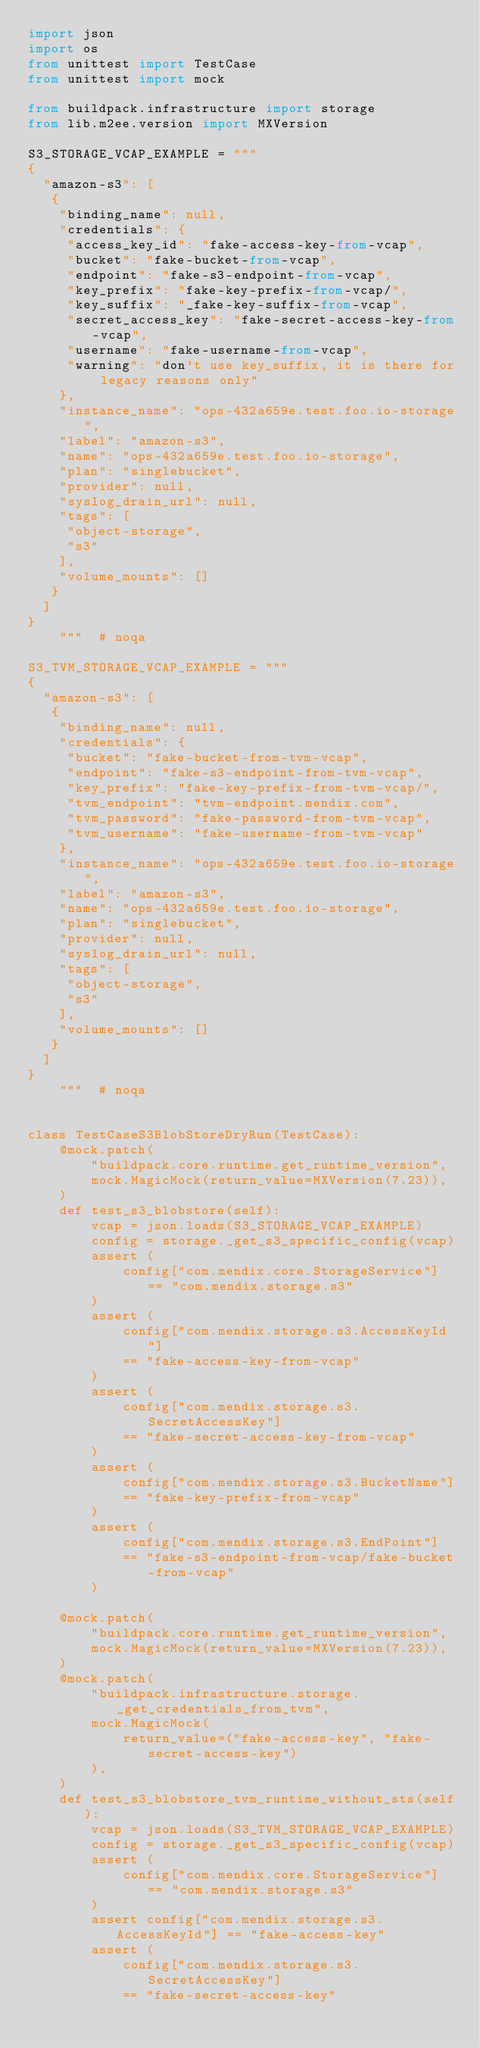<code> <loc_0><loc_0><loc_500><loc_500><_Python_>import json
import os
from unittest import TestCase
from unittest import mock

from buildpack.infrastructure import storage
from lib.m2ee.version import MXVersion

S3_STORAGE_VCAP_EXAMPLE = """
{
  "amazon-s3": [
   {
    "binding_name": null,
    "credentials": {
     "access_key_id": "fake-access-key-from-vcap",
     "bucket": "fake-bucket-from-vcap",
     "endpoint": "fake-s3-endpoint-from-vcap",
     "key_prefix": "fake-key-prefix-from-vcap/",
     "key_suffix": "_fake-key-suffix-from-vcap",
     "secret_access_key": "fake-secret-access-key-from-vcap",
     "username": "fake-username-from-vcap",
     "warning": "don't use key_suffix, it is there for legacy reasons only"
    },
    "instance_name": "ops-432a659e.test.foo.io-storage",
    "label": "amazon-s3",
    "name": "ops-432a659e.test.foo.io-storage",
    "plan": "singlebucket",
    "provider": null,
    "syslog_drain_url": null,
    "tags": [
     "object-storage",
     "s3"
    ],
    "volume_mounts": []
   }
  ]
}
    """  # noqa

S3_TVM_STORAGE_VCAP_EXAMPLE = """
{
  "amazon-s3": [
   {
    "binding_name": null,
    "credentials": {
     "bucket": "fake-bucket-from-tvm-vcap",
     "endpoint": "fake-s3-endpoint-from-tvm-vcap",
     "key_prefix": "fake-key-prefix-from-tvm-vcap/",
     "tvm_endpoint": "tvm-endpoint.mendix.com",
     "tvm_password": "fake-password-from-tvm-vcap",
     "tvm_username": "fake-username-from-tvm-vcap"
    },
    "instance_name": "ops-432a659e.test.foo.io-storage",
    "label": "amazon-s3",
    "name": "ops-432a659e.test.foo.io-storage",
    "plan": "singlebucket",
    "provider": null,
    "syslog_drain_url": null,
    "tags": [
     "object-storage",
     "s3"
    ],
    "volume_mounts": []
   }
  ]
}
    """  # noqa


class TestCaseS3BlobStoreDryRun(TestCase):
    @mock.patch(
        "buildpack.core.runtime.get_runtime_version",
        mock.MagicMock(return_value=MXVersion(7.23)),
    )
    def test_s3_blobstore(self):
        vcap = json.loads(S3_STORAGE_VCAP_EXAMPLE)
        config = storage._get_s3_specific_config(vcap)
        assert (
            config["com.mendix.core.StorageService"] == "com.mendix.storage.s3"
        )
        assert (
            config["com.mendix.storage.s3.AccessKeyId"]
            == "fake-access-key-from-vcap"
        )
        assert (
            config["com.mendix.storage.s3.SecretAccessKey"]
            == "fake-secret-access-key-from-vcap"
        )
        assert (
            config["com.mendix.storage.s3.BucketName"]
            == "fake-key-prefix-from-vcap"
        )
        assert (
            config["com.mendix.storage.s3.EndPoint"]
            == "fake-s3-endpoint-from-vcap/fake-bucket-from-vcap"
        )

    @mock.patch(
        "buildpack.core.runtime.get_runtime_version",
        mock.MagicMock(return_value=MXVersion(7.23)),
    )
    @mock.patch(
        "buildpack.infrastructure.storage._get_credentials_from_tvm",
        mock.MagicMock(
            return_value=("fake-access-key", "fake-secret-access-key")
        ),
    )
    def test_s3_blobstore_tvm_runtime_without_sts(self):
        vcap = json.loads(S3_TVM_STORAGE_VCAP_EXAMPLE)
        config = storage._get_s3_specific_config(vcap)
        assert (
            config["com.mendix.core.StorageService"] == "com.mendix.storage.s3"
        )
        assert config["com.mendix.storage.s3.AccessKeyId"] == "fake-access-key"
        assert (
            config["com.mendix.storage.s3.SecretAccessKey"]
            == "fake-secret-access-key"</code> 